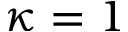<formula> <loc_0><loc_0><loc_500><loc_500>\kappa = 1</formula> 